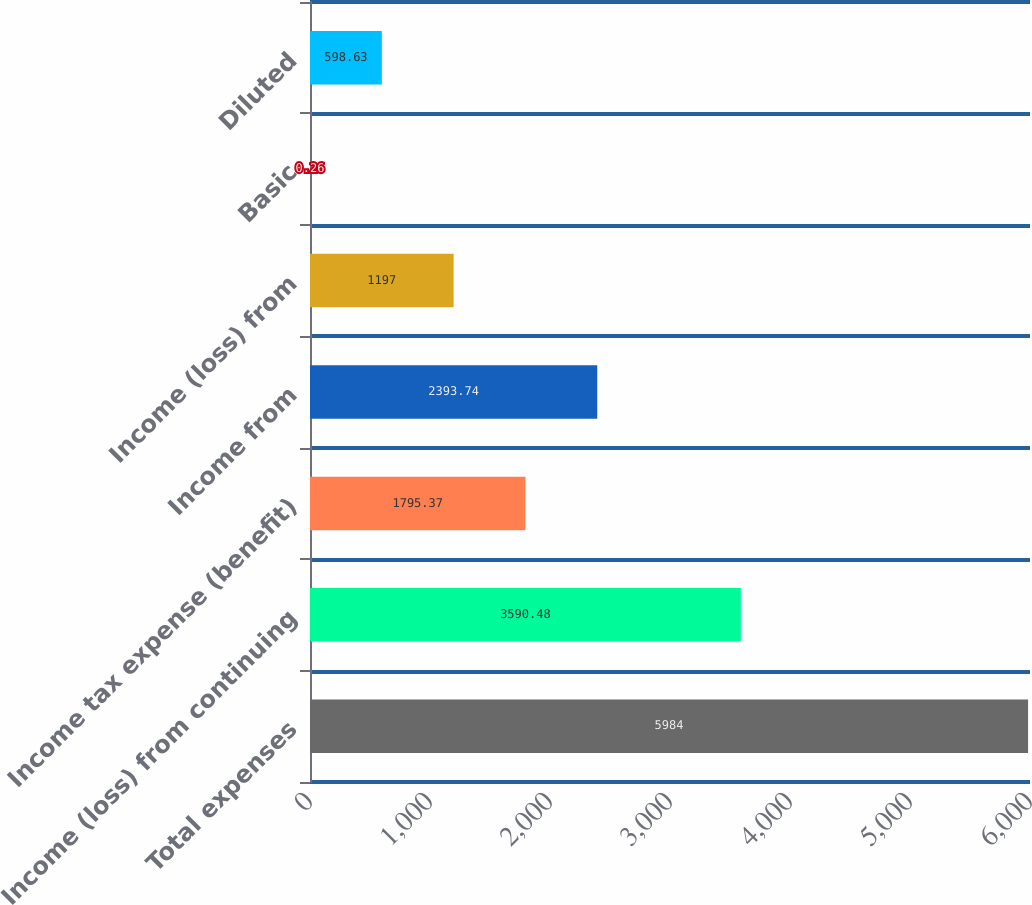Convert chart. <chart><loc_0><loc_0><loc_500><loc_500><bar_chart><fcel>Total expenses<fcel>Income (loss) from continuing<fcel>Income tax expense (benefit)<fcel>Income from<fcel>Income (loss) from<fcel>Basic<fcel>Diluted<nl><fcel>5984<fcel>3590.48<fcel>1795.37<fcel>2393.74<fcel>1197<fcel>0.26<fcel>598.63<nl></chart> 